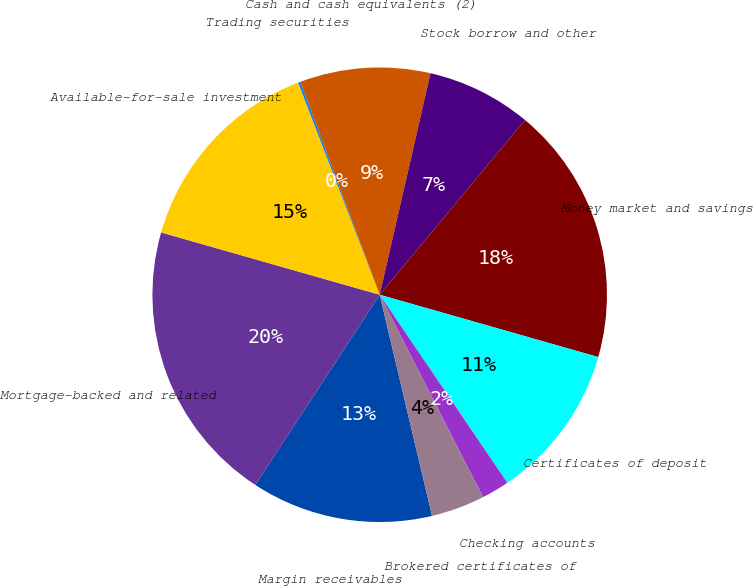Convert chart to OTSL. <chart><loc_0><loc_0><loc_500><loc_500><pie_chart><fcel>Margin receivables<fcel>Mortgage-backed and related<fcel>Available-for-sale investment<fcel>Trading securities<fcel>Cash and cash equivalents (2)<fcel>Stock borrow and other<fcel>Money market and savings<fcel>Certificates of deposit<fcel>Checking accounts<fcel>Brokered certificates of<nl><fcel>12.92%<fcel>20.2%<fcel>14.74%<fcel>0.16%<fcel>9.27%<fcel>7.45%<fcel>18.38%<fcel>11.09%<fcel>1.98%<fcel>3.81%<nl></chart> 